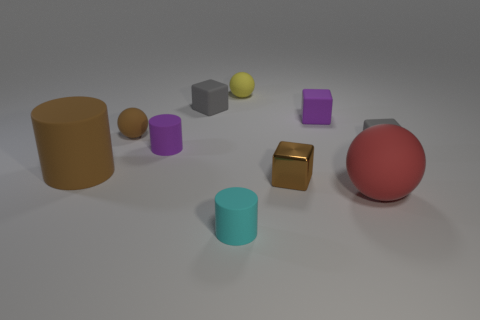Are there any other things that are the same material as the brown block?
Provide a short and direct response. No. There is a big thing that is the same color as the metallic cube; what material is it?
Offer a terse response. Rubber. How many tiny objects are cyan cylinders or red matte things?
Provide a short and direct response. 1. What is the shape of the big matte thing that is left of the big red matte thing?
Make the answer very short. Cylinder. Are there any tiny metallic objects of the same color as the big rubber cylinder?
Ensure brevity in your answer.  Yes. Do the purple thing right of the small yellow sphere and the gray object in front of the purple matte cylinder have the same size?
Ensure brevity in your answer.  Yes. Are there more gray objects that are in front of the brown matte sphere than big brown things that are right of the cyan object?
Provide a short and direct response. Yes. Are there any brown objects made of the same material as the tiny cyan cylinder?
Provide a short and direct response. Yes. Is the tiny shiny object the same color as the big cylinder?
Your answer should be compact. Yes. What is the material of the sphere that is behind the purple cylinder and to the right of the cyan matte cylinder?
Keep it short and to the point. Rubber. 